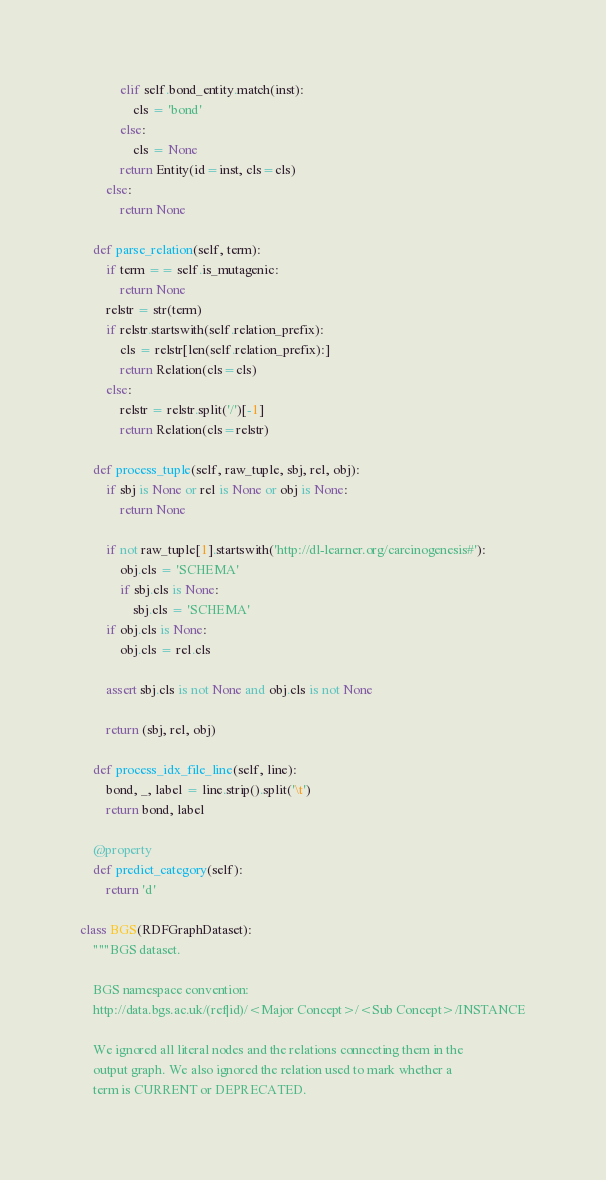Convert code to text. <code><loc_0><loc_0><loc_500><loc_500><_Python_>            elif self.bond_entity.match(inst):
                cls = 'bond'
            else:
                cls = None
            return Entity(id=inst, cls=cls)
        else:
            return None

    def parse_relation(self, term):
        if term == self.is_mutagenic:
            return None
        relstr = str(term)
        if relstr.startswith(self.relation_prefix):
            cls = relstr[len(self.relation_prefix):]
            return Relation(cls=cls)
        else:
            relstr = relstr.split('/')[-1]
            return Relation(cls=relstr)

    def process_tuple(self, raw_tuple, sbj, rel, obj):
        if sbj is None or rel is None or obj is None:
            return None

        if not raw_tuple[1].startswith('http://dl-learner.org/carcinogenesis#'):
            obj.cls = 'SCHEMA'
            if sbj.cls is None:
                sbj.cls = 'SCHEMA'
        if obj.cls is None:
            obj.cls = rel.cls

        assert sbj.cls is not None and obj.cls is not None
        
        return (sbj, rel, obj)

    def process_idx_file_line(self, line):
        bond, _, label = line.strip().split('\t')
        return bond, label

    @property
    def predict_category(self):
        return 'd'

class BGS(RDFGraphDataset):
    """BGS dataset.

    BGS namespace convention:
    http://data.bgs.ac.uk/(ref|id)/<Major Concept>/<Sub Concept>/INSTANCE

    We ignored all literal nodes and the relations connecting them in the
    output graph. We also ignored the relation used to mark whether a
    term is CURRENT or DEPRECATED.
</code> 